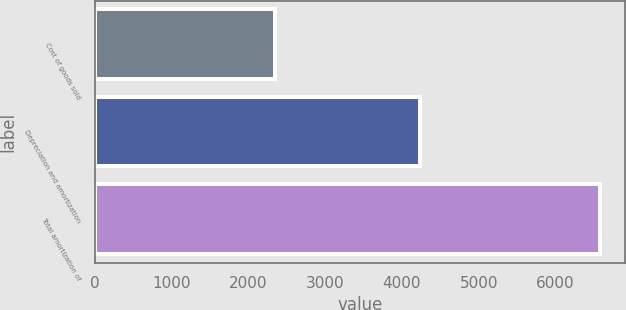Convert chart to OTSL. <chart><loc_0><loc_0><loc_500><loc_500><bar_chart><fcel>Cost of goods sold<fcel>Depreciation and amortization<fcel>Total amortization of<nl><fcel>2350<fcel>4229<fcel>6579<nl></chart> 